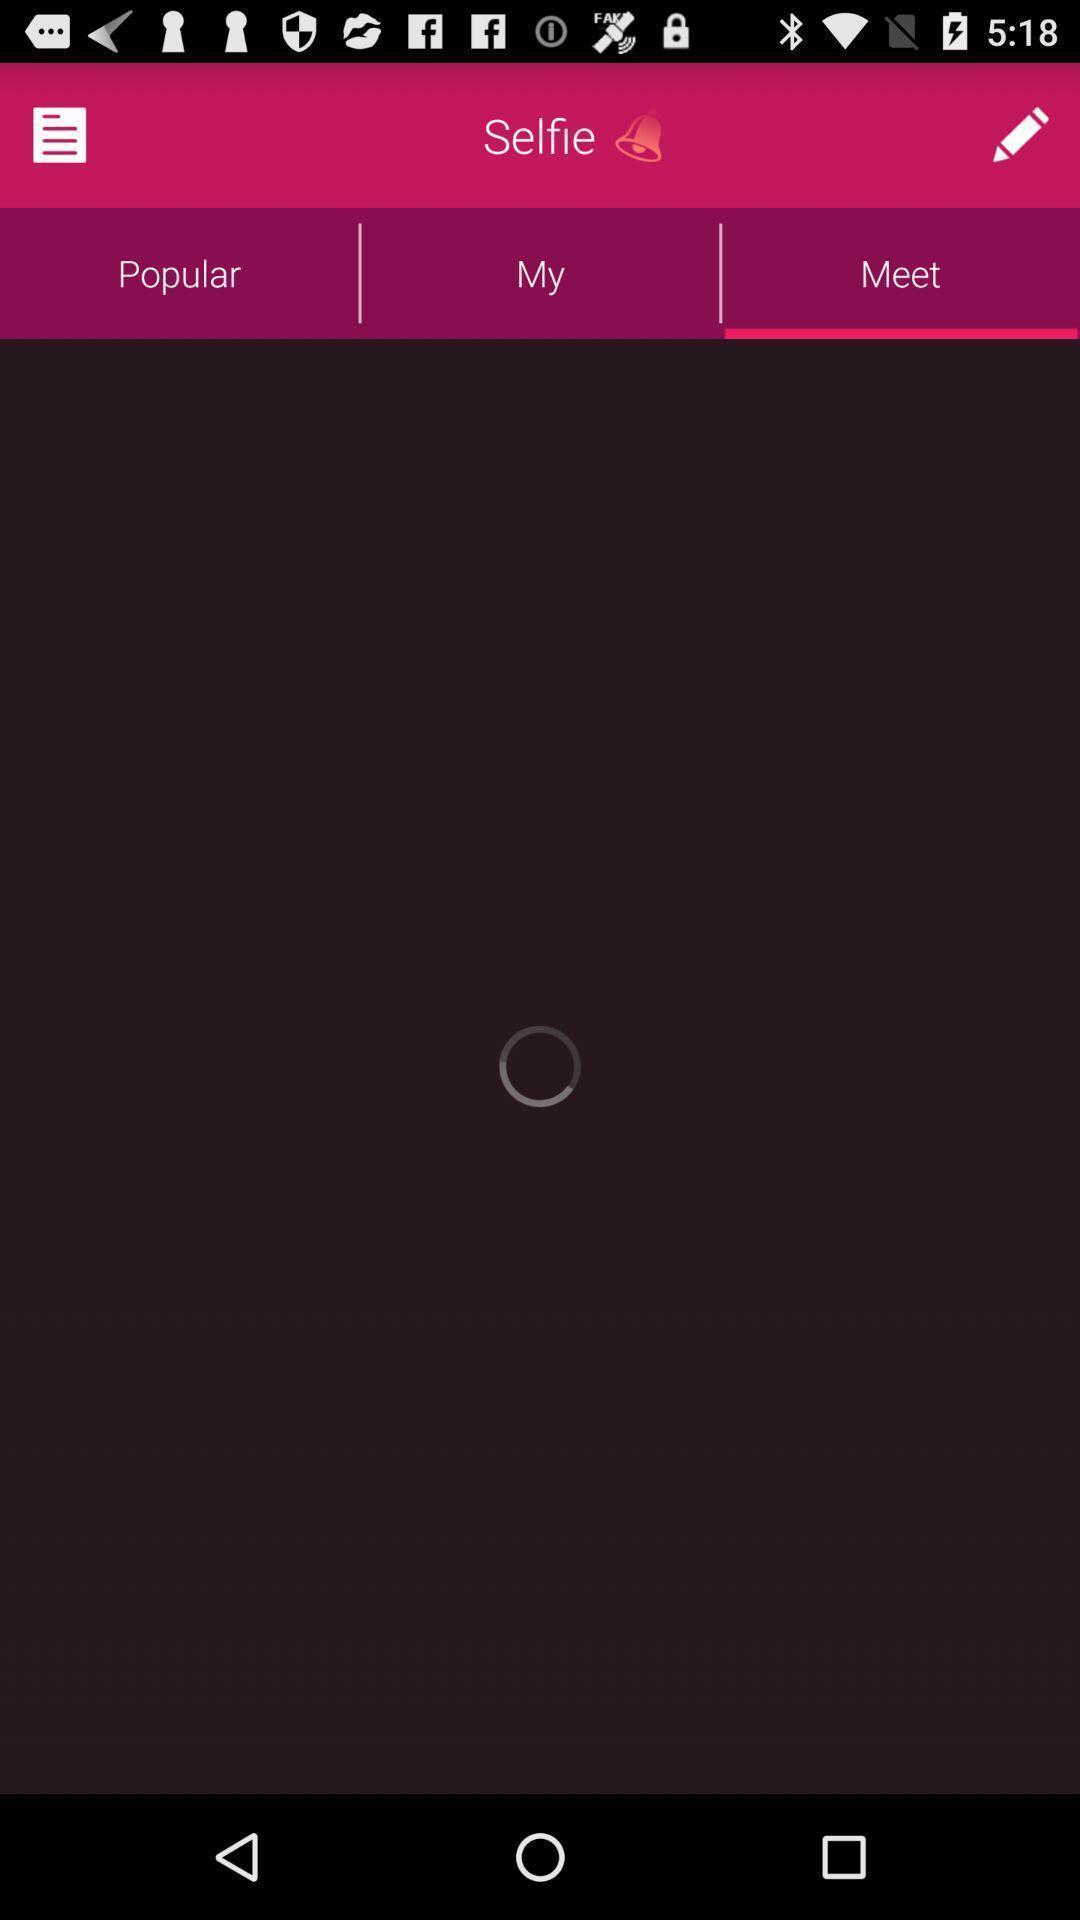Tell me about the visual elements in this screen capture. Screen shows meet option in a communication app. 